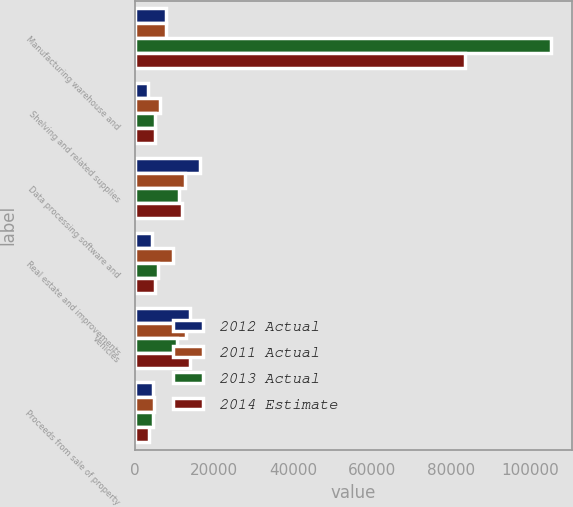Convert chart to OTSL. <chart><loc_0><loc_0><loc_500><loc_500><stacked_bar_chart><ecel><fcel>Manufacturing warehouse and<fcel>Shelving and related supplies<fcel>Data processing software and<fcel>Real estate and improvements<fcel>Vehicles<fcel>Proceeds from sale of property<nl><fcel>2012 Actual<fcel>7978.5<fcel>3400<fcel>16500<fcel>4500<fcel>13900<fcel>4600<nl><fcel>2011 Actual<fcel>7978.5<fcel>6354<fcel>12652<fcel>9603<fcel>12991<fcel>4990<nl><fcel>2013 Actual<fcel>105278<fcel>5240<fcel>11102<fcel>6014<fcel>10772<fcel>4524<nl><fcel>2014 Estimate<fcel>83607<fcel>5259<fcel>12036<fcel>5157<fcel>13984<fcel>3554<nl></chart> 